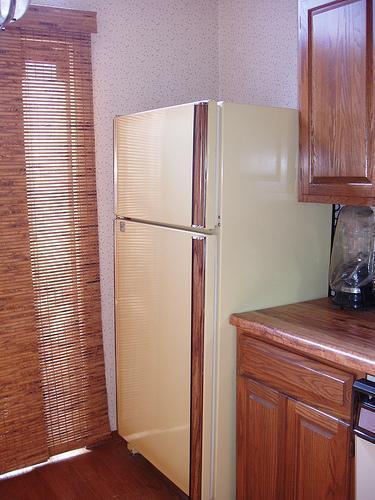How many refrigerators are there?
Give a very brief answer. 1. 